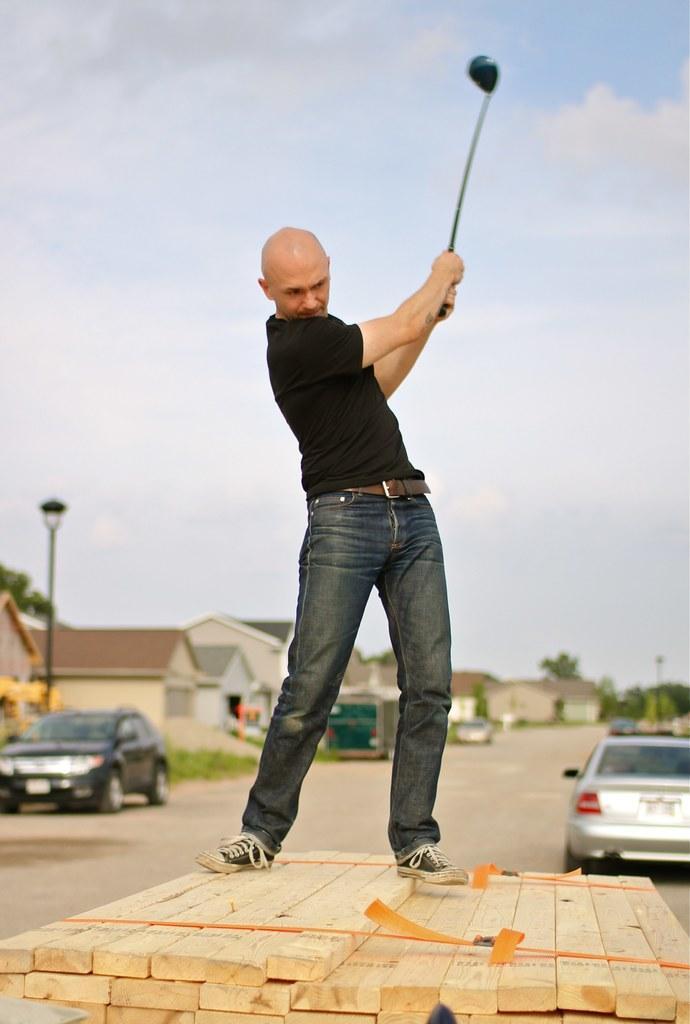Describe this image in one or two sentences. In this picture there is a man standing on wooden planks and holding a stick. In the background of the image we can see vehicles on the road, grass, trees, houses, poles and sky with clouds. 